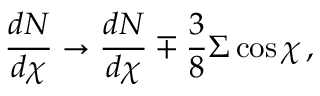Convert formula to latex. <formula><loc_0><loc_0><loc_500><loc_500>{ \frac { d N } { d \chi } } \to { \frac { d N } { d \chi } } \mp { \frac { 3 } { 8 } } \Sigma \cos \chi \, ,</formula> 